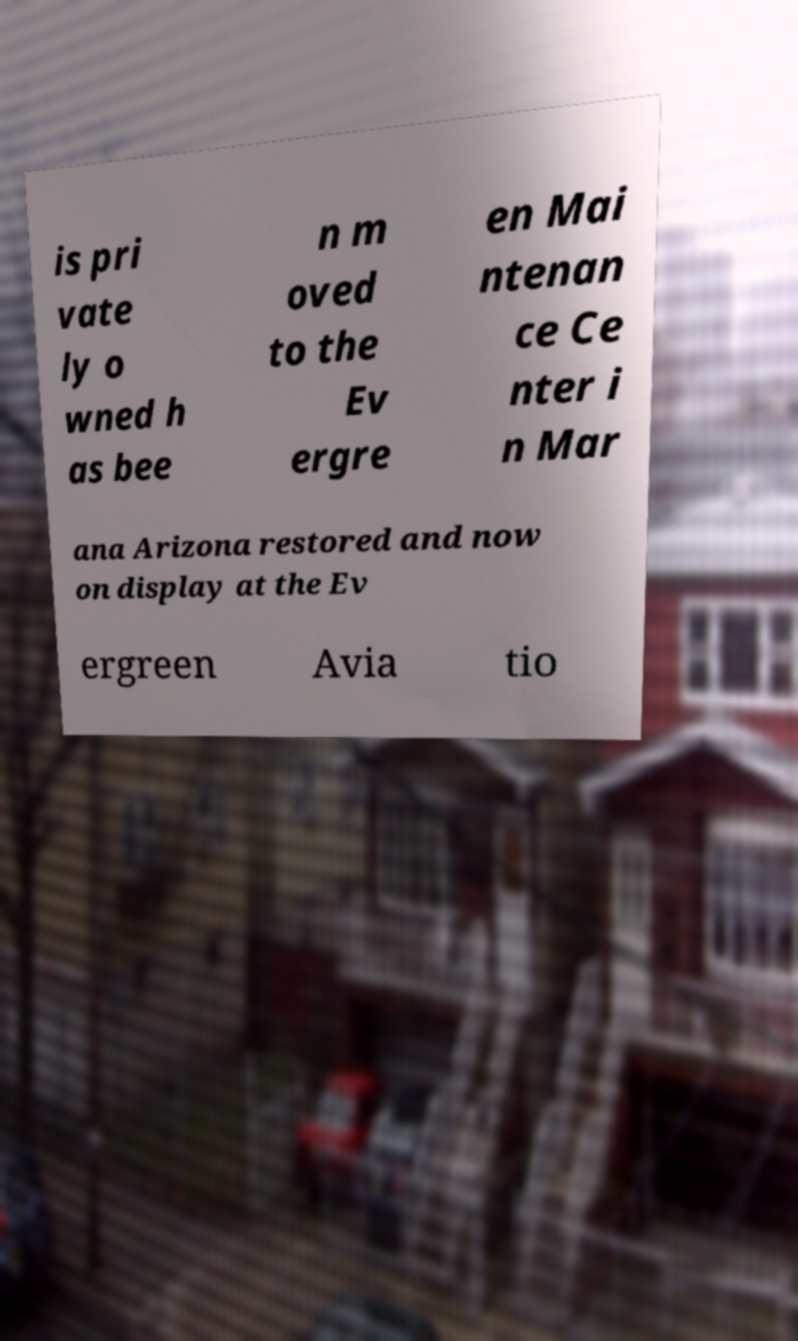Can you accurately transcribe the text from the provided image for me? is pri vate ly o wned h as bee n m oved to the Ev ergre en Mai ntenan ce Ce nter i n Mar ana Arizona restored and now on display at the Ev ergreen Avia tio 